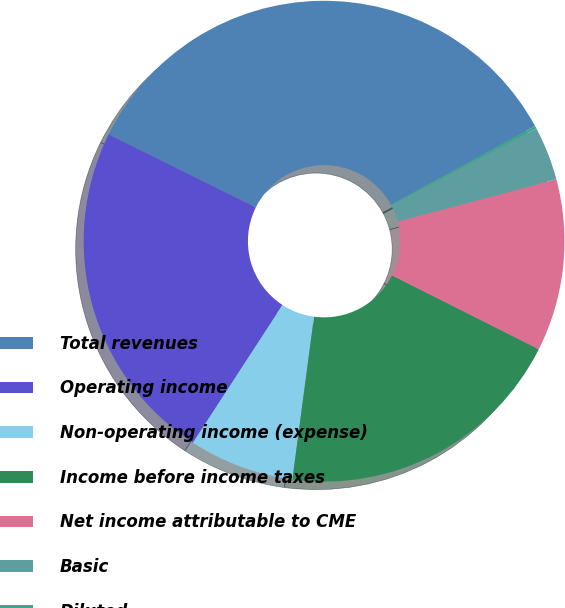<chart> <loc_0><loc_0><loc_500><loc_500><pie_chart><fcel>Total revenues<fcel>Operating income<fcel>Non-operating income (expense)<fcel>Income before income taxes<fcel>Net income attributable to CME<fcel>Basic<fcel>Diluted<nl><fcel>34.73%<fcel>23.14%<fcel>7.08%<fcel>19.68%<fcel>11.57%<fcel>3.63%<fcel>0.17%<nl></chart> 